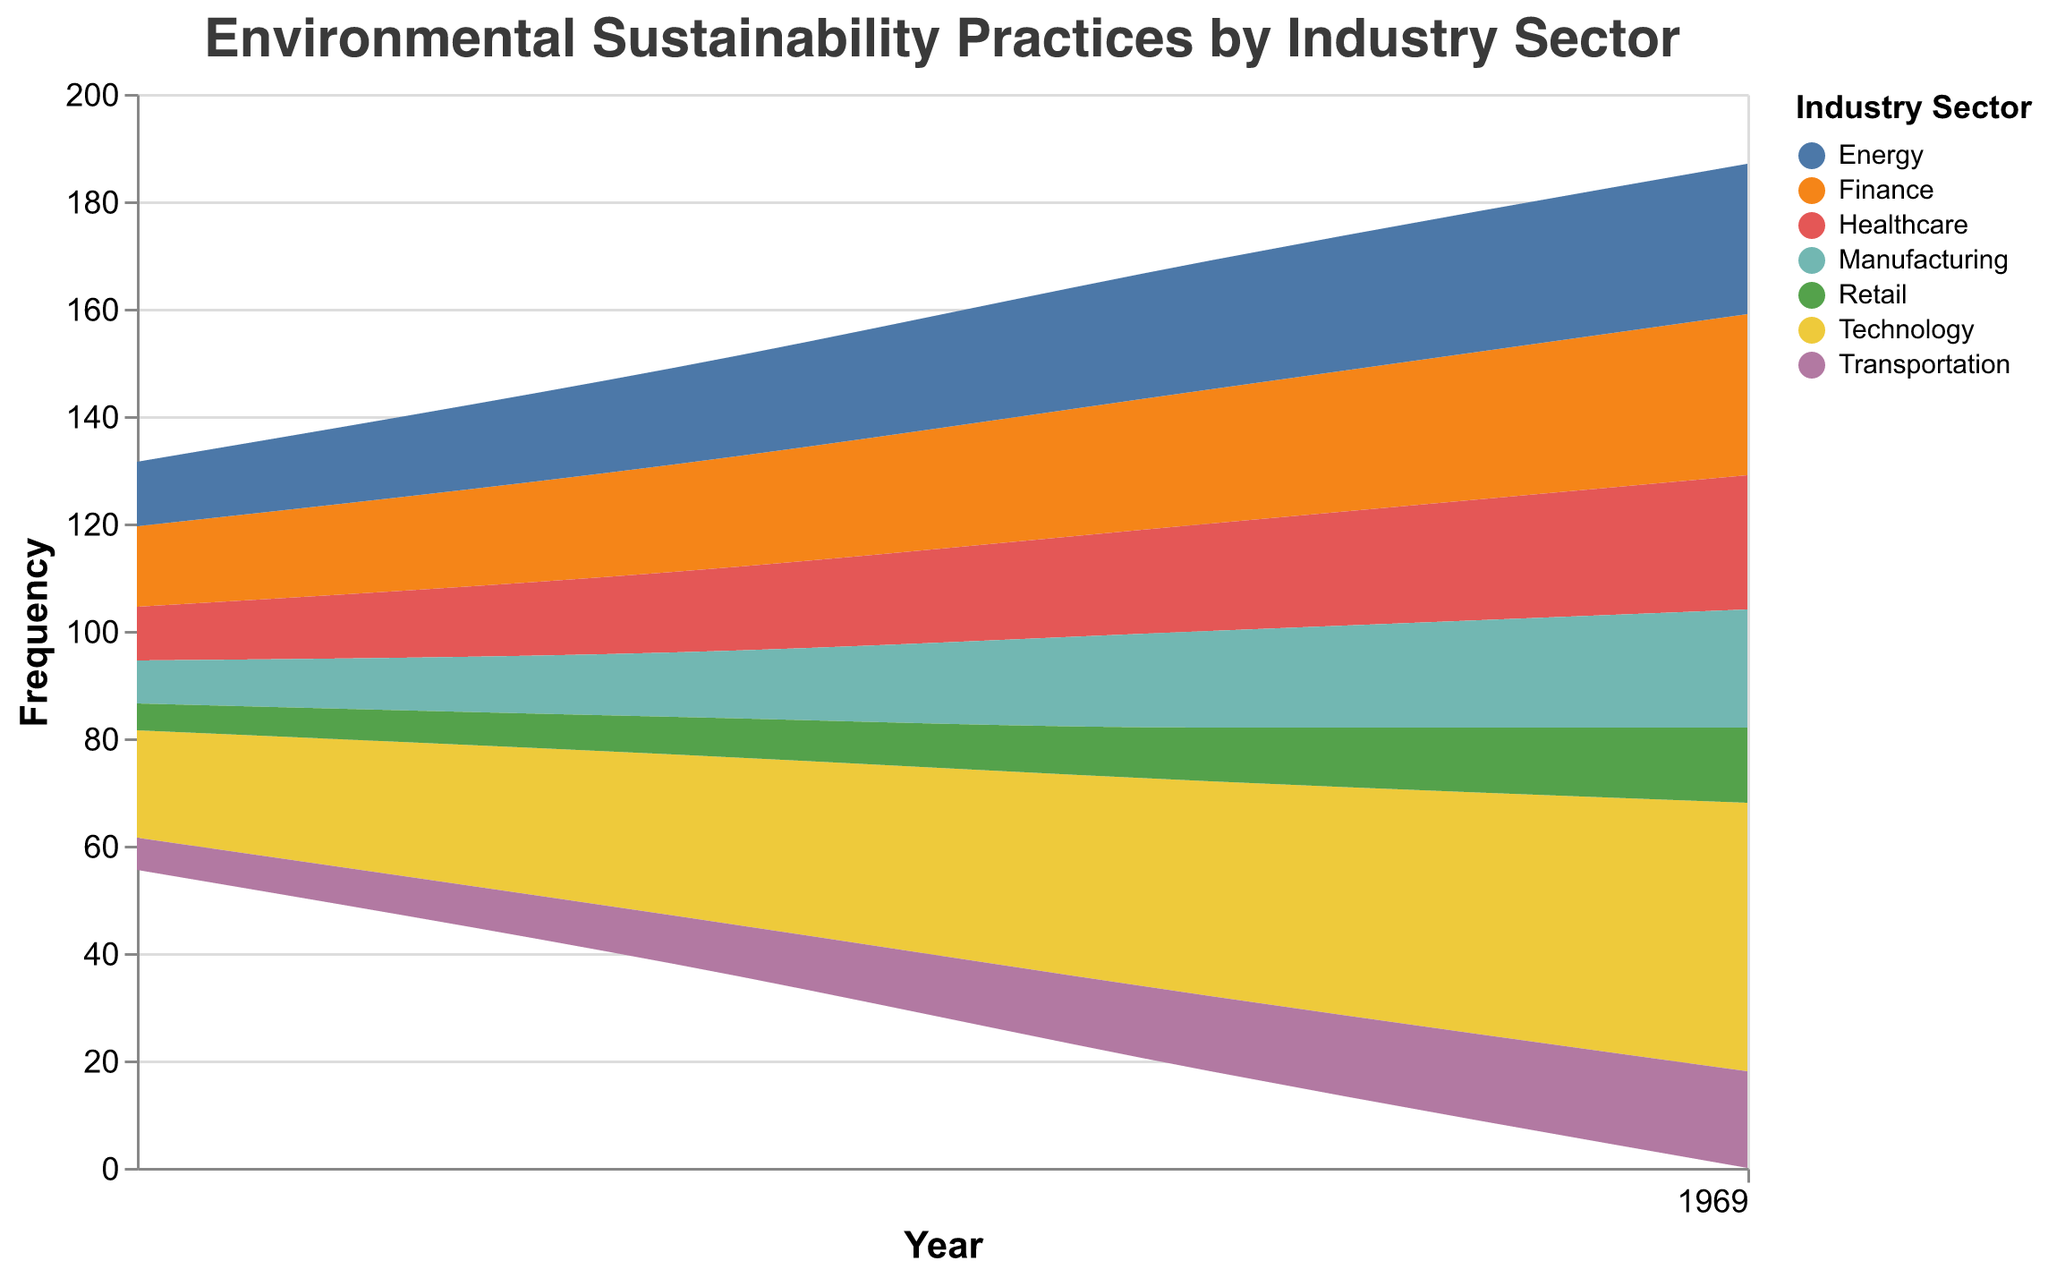What is the title of the figure? The title is written at the top of the figure, indicating the subject of the data displayed.
Answer: Environmental Sustainability Practices by Industry Sector What is the frequency of environmental sustainability practices in the Technology sector for the year 2022? Locate the Technology sector in the legend, then track its section in the stream graph to the year 2022 on the x-axis and read the value on the y-axis.
Answer: 50 Which industry sector had the lowest frequency of environmental sustainability practices in 2019? Identify all the sections corresponding to the year 2019 on the x-axis and determine which one reaches the lowest value on the y-axis.
Answer: Retail How did the frequency of environmental sustainability practices in the Healthcare sector change from 2019 to 2022? Locate the Healthcare sector in the legend, then trace its section from 2019 to 2022 on the x-axis and compare the values on the y-axis.
Answer: Increased from 10 to 25 Which sector showed the most significant increase in frequency of environmental sustainability practices from 2019 to 2022? Calculate the difference in the values for each sector from 2019 to 2022 and identify the sector with the highest difference.
Answer: Technology What was the average frequency of environmental sustainability practices across all sectors in 2020? Sum the frequencies for all sectors in 2020 and divide by the number of sectors.
Answer: (30 + 20 + 15 + 12 + 7 + 18 + 9) / 7 = 111 / 7 = 15.86 Compare the frequencies of environmental sustainability practices between the Finance and Energy sectors in 2021. Which is higher? Locate both sectors in the legend and track their sections to the year 2021 on the x-axis, then compare their values on the y-axis.
Answer: Energy What pattern or trend can be observed in the frequency of environmental sustainability practices in the Transportation sector over the four years? Trace the section for the Transportation sector from 2019 to 2022 on the x-axis and observe the changes in the values on the y-axis.
Answer: Increasing trend By how much did the frequency of environmental sustainability practices in the Manufacturing sector increase between 2020 and 2022? Find the values for the Manufacturing sector in 2020 and 2022, then subtract the 2020 value from the 2022 value.
Answer: 22 - 12 = 10 